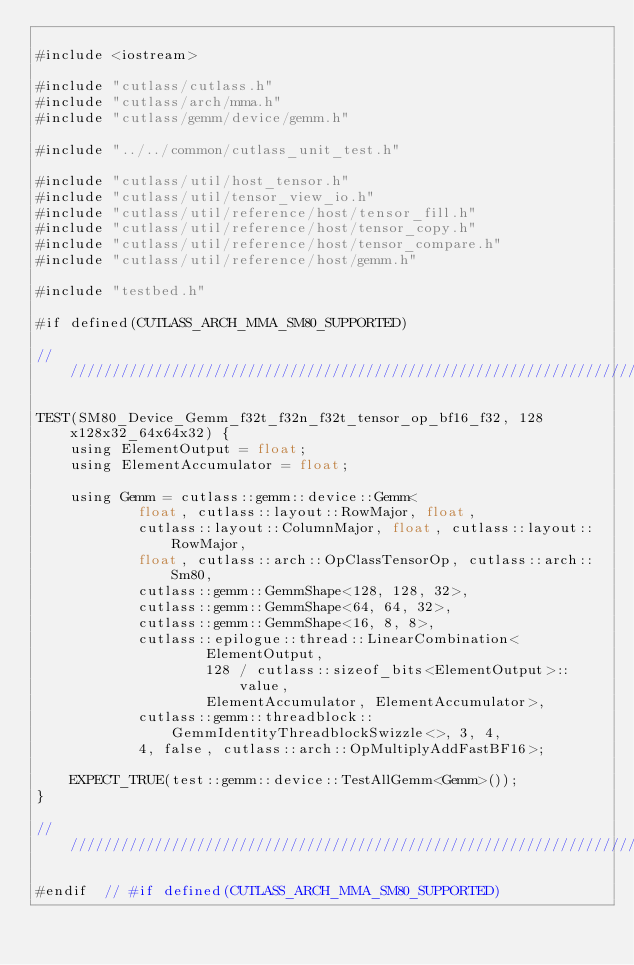<code> <loc_0><loc_0><loc_500><loc_500><_Cuda_>
#include <iostream>

#include "cutlass/cutlass.h"
#include "cutlass/arch/mma.h"
#include "cutlass/gemm/device/gemm.h"

#include "../../common/cutlass_unit_test.h"

#include "cutlass/util/host_tensor.h"
#include "cutlass/util/tensor_view_io.h"
#include "cutlass/util/reference/host/tensor_fill.h"
#include "cutlass/util/reference/host/tensor_copy.h"
#include "cutlass/util/reference/host/tensor_compare.h"
#include "cutlass/util/reference/host/gemm.h"

#include "testbed.h"

#if defined(CUTLASS_ARCH_MMA_SM80_SUPPORTED)

/////////////////////////////////////////////////////////////////////////////////////////////////

TEST(SM80_Device_Gemm_f32t_f32n_f32t_tensor_op_bf16_f32, 128x128x32_64x64x32) {
    using ElementOutput = float;
    using ElementAccumulator = float;

    using Gemm = cutlass::gemm::device::Gemm<
            float, cutlass::layout::RowMajor, float,
            cutlass::layout::ColumnMajor, float, cutlass::layout::RowMajor,
            float, cutlass::arch::OpClassTensorOp, cutlass::arch::Sm80,
            cutlass::gemm::GemmShape<128, 128, 32>,
            cutlass::gemm::GemmShape<64, 64, 32>,
            cutlass::gemm::GemmShape<16, 8, 8>,
            cutlass::epilogue::thread::LinearCombination<
                    ElementOutput,
                    128 / cutlass::sizeof_bits<ElementOutput>::value,
                    ElementAccumulator, ElementAccumulator>,
            cutlass::gemm::threadblock::GemmIdentityThreadblockSwizzle<>, 3, 4,
            4, false, cutlass::arch::OpMultiplyAddFastBF16>;

    EXPECT_TRUE(test::gemm::device::TestAllGemm<Gemm>());
}

/////////////////////////////////////////////////////////////////////////////////////////////////

#endif  // #if defined(CUTLASS_ARCH_MMA_SM80_SUPPORTED)
</code> 